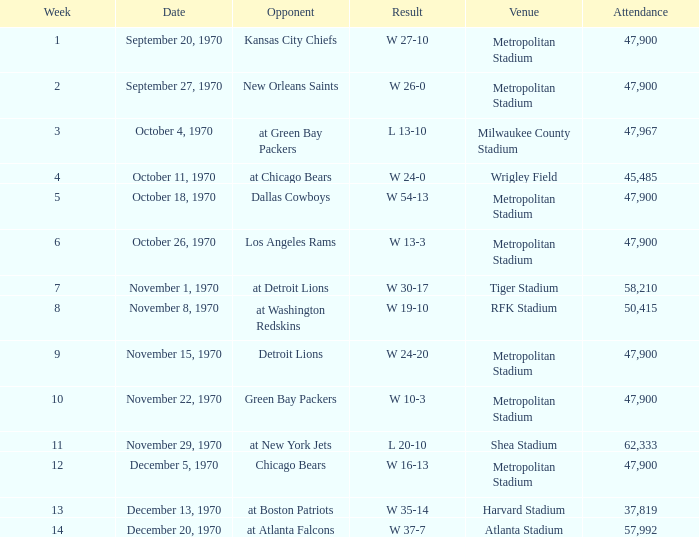What was the attendance count for the game that had a score of 16-13 and took place a week before week 12? None. 